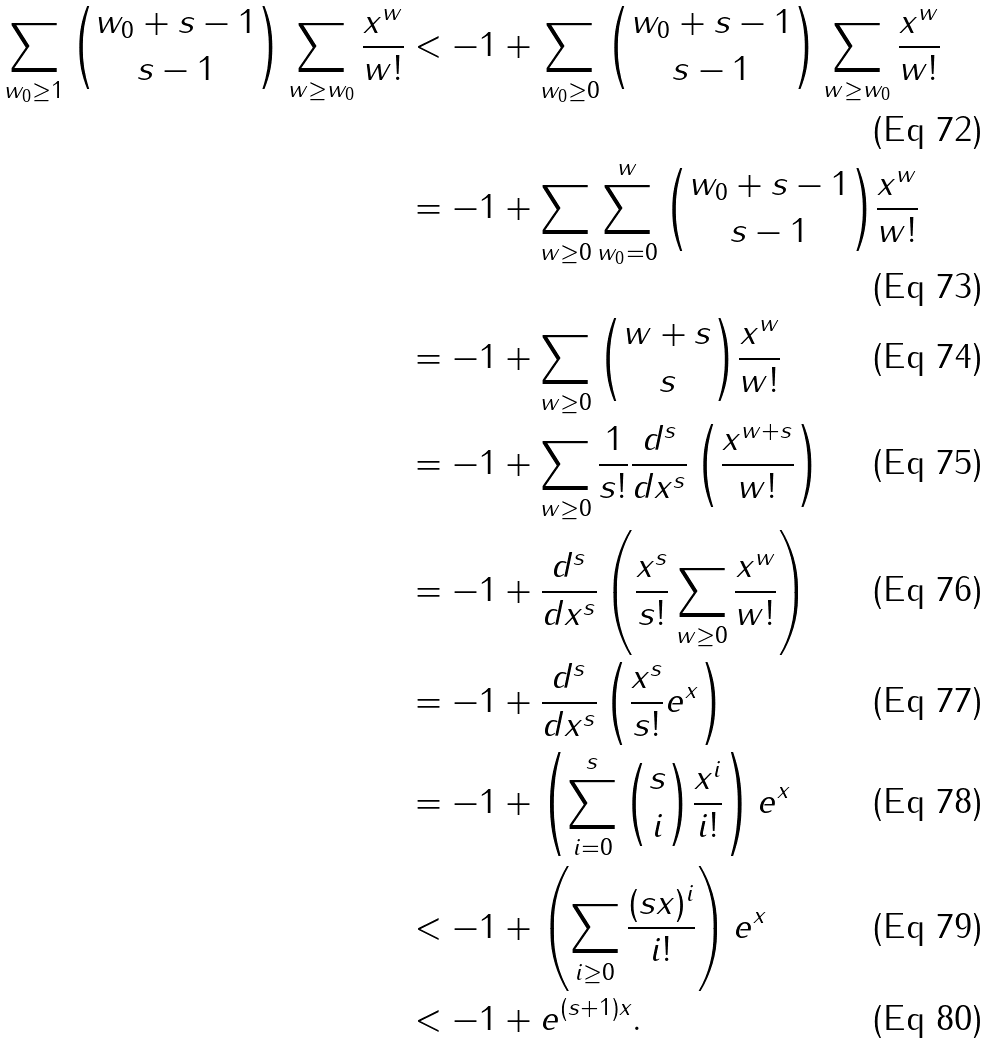<formula> <loc_0><loc_0><loc_500><loc_500>\sum _ { w _ { 0 } \geq 1 } { w _ { 0 } + s - 1 \choose s - 1 } \sum _ { w \geq w _ { 0 } } \frac { x ^ { w } } { w ! } & < - 1 + \sum _ { w _ { 0 } \geq 0 } { w _ { 0 } + s - 1 \choose s - 1 } \sum _ { w \geq w _ { 0 } } \frac { x ^ { w } } { w ! } \\ & = - 1 + \sum _ { w \geq 0 } \sum _ { w _ { 0 } = 0 } ^ { w } { w _ { 0 } + s - 1 \choose s - 1 } \frac { x ^ { w } } { w ! } \\ & = - 1 + \sum _ { w \geq 0 } { w + s \choose s } \frac { x ^ { w } } { w ! } \\ & = - 1 + \sum _ { w \geq 0 } \frac { 1 } { s ! } \frac { d ^ { s } } { d x ^ { s } } \left ( \frac { x ^ { w + s } } { w ! } \right ) \\ & = - 1 + \frac { d ^ { s } } { d x ^ { s } } \left ( \frac { x ^ { s } } { s ! } \sum _ { w \geq 0 } \frac { x ^ { w } } { w ! } \right ) \\ & = - 1 + \frac { d ^ { s } } { d x ^ { s } } \left ( \frac { x ^ { s } } { s ! } e ^ { x } \right ) \\ & = - 1 + \left ( \sum _ { i = 0 } ^ { s } { s \choose i } \frac { x ^ { i } } { i ! } \right ) e ^ { x } \\ & < - 1 + \left ( \sum _ { i \geq 0 } \frac { ( s x ) ^ { i } } { i ! } \right ) e ^ { x } \\ & < - 1 + e ^ { ( s + 1 ) x } .</formula> 